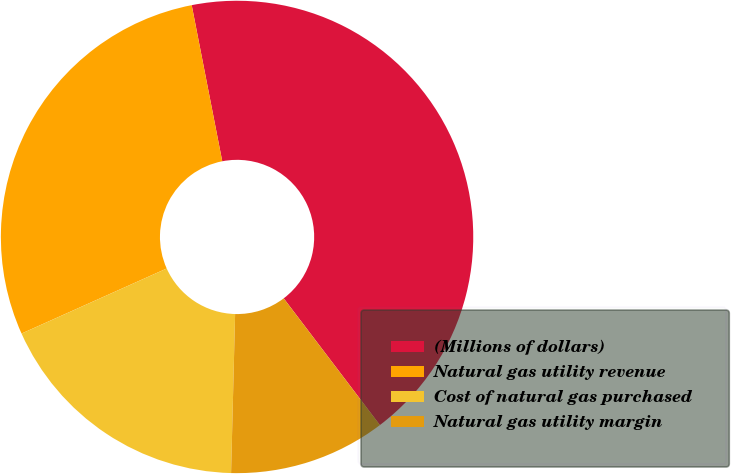Convert chart. <chart><loc_0><loc_0><loc_500><loc_500><pie_chart><fcel>(Millions of dollars)<fcel>Natural gas utility revenue<fcel>Cost of natural gas purchased<fcel>Natural gas utility margin<nl><fcel>42.74%<fcel>28.63%<fcel>17.89%<fcel>10.74%<nl></chart> 